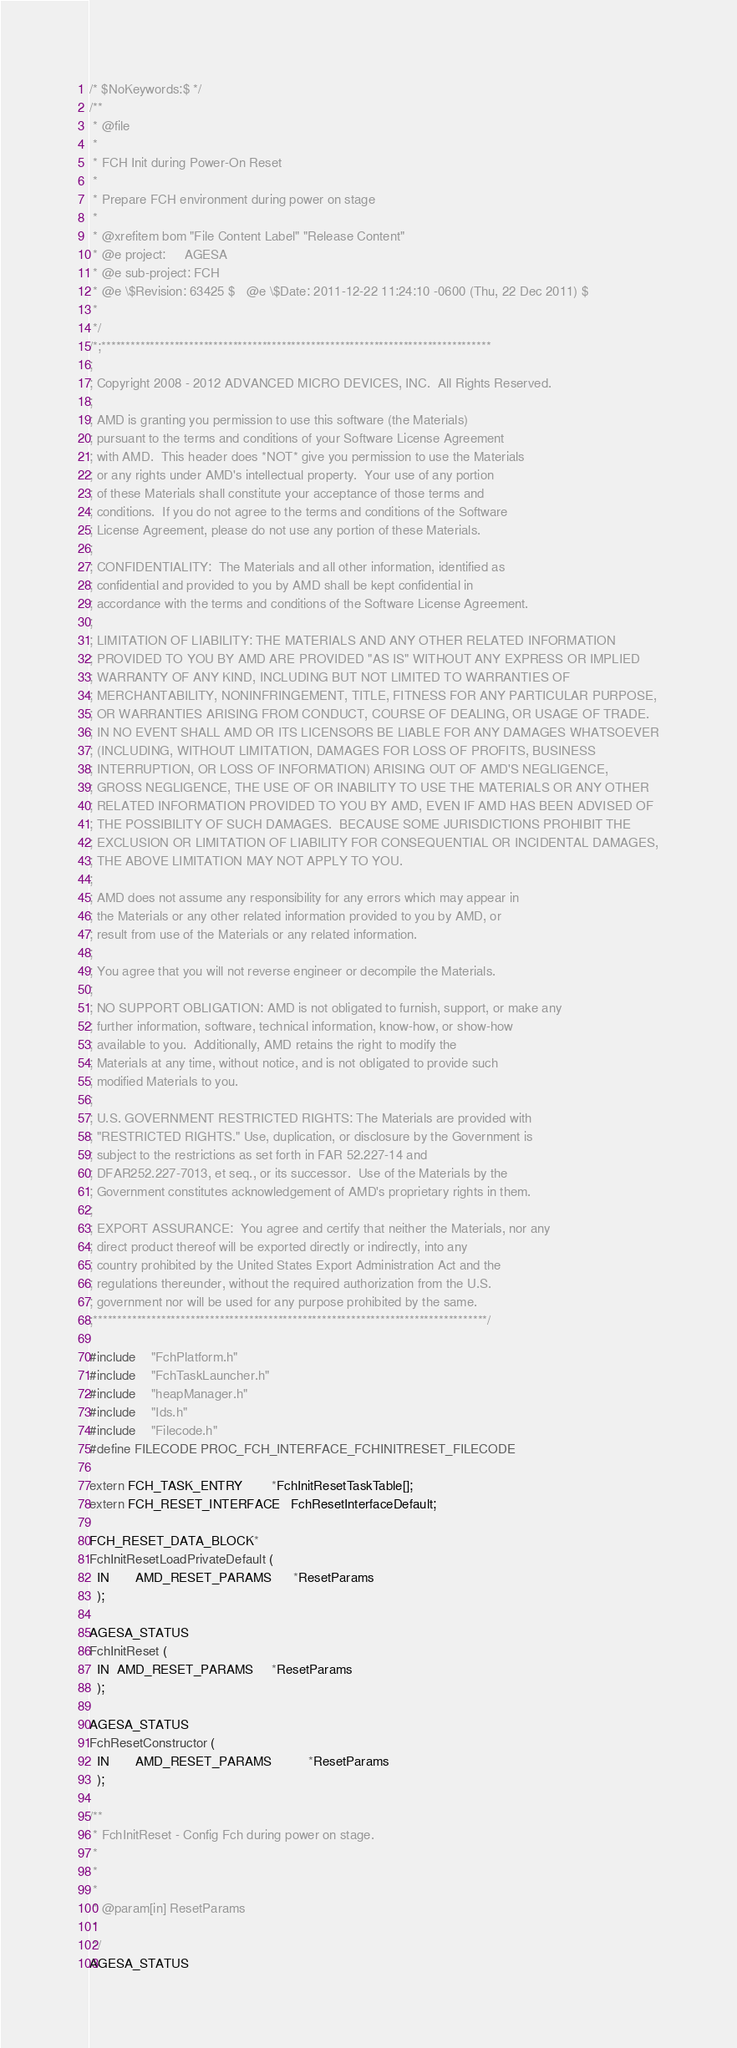Convert code to text. <code><loc_0><loc_0><loc_500><loc_500><_C_>/* $NoKeywords:$ */
/**
 * @file
 *
 * FCH Init during Power-On Reset
 *
 * Prepare FCH environment during power on stage
 *
 * @xrefitem bom "File Content Label" "Release Content"
 * @e project:     AGESA
 * @e sub-project: FCH
 * @e \$Revision: 63425 $   @e \$Date: 2011-12-22 11:24:10 -0600 (Thu, 22 Dec 2011) $
 *
 */
/*;********************************************************************************
;
; Copyright 2008 - 2012 ADVANCED MICRO DEVICES, INC.  All Rights Reserved.
;
; AMD is granting you permission to use this software (the Materials)
; pursuant to the terms and conditions of your Software License Agreement
; with AMD.  This header does *NOT* give you permission to use the Materials
; or any rights under AMD's intellectual property.  Your use of any portion
; of these Materials shall constitute your acceptance of those terms and
; conditions.  If you do not agree to the terms and conditions of the Software
; License Agreement, please do not use any portion of these Materials.
;
; CONFIDENTIALITY:  The Materials and all other information, identified as
; confidential and provided to you by AMD shall be kept confidential in
; accordance with the terms and conditions of the Software License Agreement.
;
; LIMITATION OF LIABILITY: THE MATERIALS AND ANY OTHER RELATED INFORMATION
; PROVIDED TO YOU BY AMD ARE PROVIDED "AS IS" WITHOUT ANY EXPRESS OR IMPLIED
; WARRANTY OF ANY KIND, INCLUDING BUT NOT LIMITED TO WARRANTIES OF
; MERCHANTABILITY, NONINFRINGEMENT, TITLE, FITNESS FOR ANY PARTICULAR PURPOSE,
; OR WARRANTIES ARISING FROM CONDUCT, COURSE OF DEALING, OR USAGE OF TRADE.
; IN NO EVENT SHALL AMD OR ITS LICENSORS BE LIABLE FOR ANY DAMAGES WHATSOEVER
; (INCLUDING, WITHOUT LIMITATION, DAMAGES FOR LOSS OF PROFITS, BUSINESS
; INTERRUPTION, OR LOSS OF INFORMATION) ARISING OUT OF AMD'S NEGLIGENCE,
; GROSS NEGLIGENCE, THE USE OF OR INABILITY TO USE THE MATERIALS OR ANY OTHER
; RELATED INFORMATION PROVIDED TO YOU BY AMD, EVEN IF AMD HAS BEEN ADVISED OF
; THE POSSIBILITY OF SUCH DAMAGES.  BECAUSE SOME JURISDICTIONS PROHIBIT THE
; EXCLUSION OR LIMITATION OF LIABILITY FOR CONSEQUENTIAL OR INCIDENTAL DAMAGES,
; THE ABOVE LIMITATION MAY NOT APPLY TO YOU.
;
; AMD does not assume any responsibility for any errors which may appear in
; the Materials or any other related information provided to you by AMD, or
; result from use of the Materials or any related information.
;
; You agree that you will not reverse engineer or decompile the Materials.
;
; NO SUPPORT OBLIGATION: AMD is not obligated to furnish, support, or make any
; further information, software, technical information, know-how, or show-how
; available to you.  Additionally, AMD retains the right to modify the
; Materials at any time, without notice, and is not obligated to provide such
; modified Materials to you.
;
; U.S. GOVERNMENT RESTRICTED RIGHTS: The Materials are provided with
; "RESTRICTED RIGHTS." Use, duplication, or disclosure by the Government is
; subject to the restrictions as set forth in FAR 52.227-14 and
; DFAR252.227-7013, et seq., or its successor.  Use of the Materials by the
; Government constitutes acknowledgement of AMD's proprietary rights in them.
;
; EXPORT ASSURANCE:  You agree and certify that neither the Materials, nor any
; direct product thereof will be exported directly or indirectly, into any
; country prohibited by the United States Export Administration Act and the
; regulations thereunder, without the required authorization from the U.S.
; government nor will be used for any purpose prohibited by the same.
;*********************************************************************************/

#include    "FchPlatform.h"
#include    "FchTaskLauncher.h"
#include    "heapManager.h"
#include    "Ids.h"
#include    "Filecode.h"
#define FILECODE PROC_FCH_INTERFACE_FCHINITRESET_FILECODE

extern FCH_TASK_ENTRY        *FchInitResetTaskTable[];
extern FCH_RESET_INTERFACE   FchResetInterfaceDefault;

FCH_RESET_DATA_BLOCK*
FchInitResetLoadPrivateDefault (
  IN       AMD_RESET_PARAMS      *ResetParams
  );

AGESA_STATUS
FchInitReset (
  IN  AMD_RESET_PARAMS     *ResetParams
  );

AGESA_STATUS
FchResetConstructor (
  IN       AMD_RESET_PARAMS          *ResetParams
  );

/**
 * FchInitReset - Config Fch during power on stage.
 *
 *
 *
 * @param[in] ResetParams
 *
 */
AGESA_STATUS</code> 